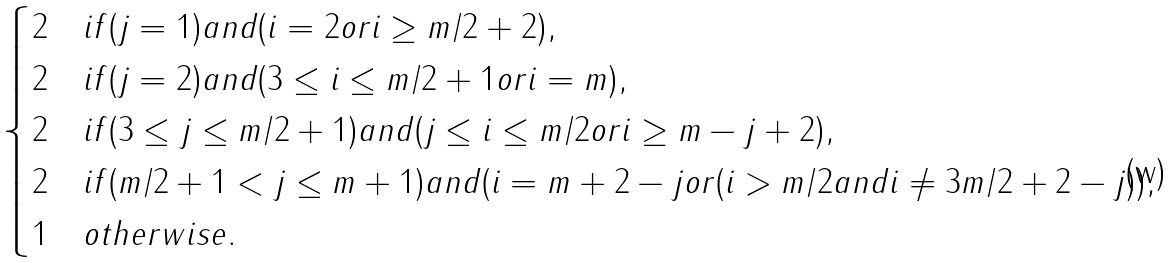Convert formula to latex. <formula><loc_0><loc_0><loc_500><loc_500>\begin{cases} 2 & i f ( j = 1 ) a n d ( i = 2 o r i \geq m / 2 + 2 ) , \\ 2 & i f ( j = 2 ) a n d ( 3 \leq i \leq m / 2 + 1 o r i = m ) , \\ 2 & i f ( 3 \leq j \leq m / 2 + 1 ) a n d ( j \leq i \leq m / 2 o r i \geq m - j + 2 ) , \\ 2 & i f ( m / 2 + 1 < j \leq m + 1 ) a n d ( i = m + 2 - j o r ( i > m / 2 a n d i \ne 3 m / 2 + 2 - j ) ) , \\ 1 & o t h e r w i s e . \end{cases}</formula> 